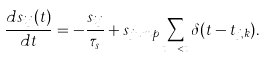Convert formula to latex. <formula><loc_0><loc_0><loc_500><loc_500>\frac { d s _ { i j } ( t ) } { d t } = - \frac { s _ { i j } } { \tau _ { s } } + s _ { j u m p } \sum _ { t _ { j , k } < t } \delta ( t - t _ { j , k } ) .</formula> 